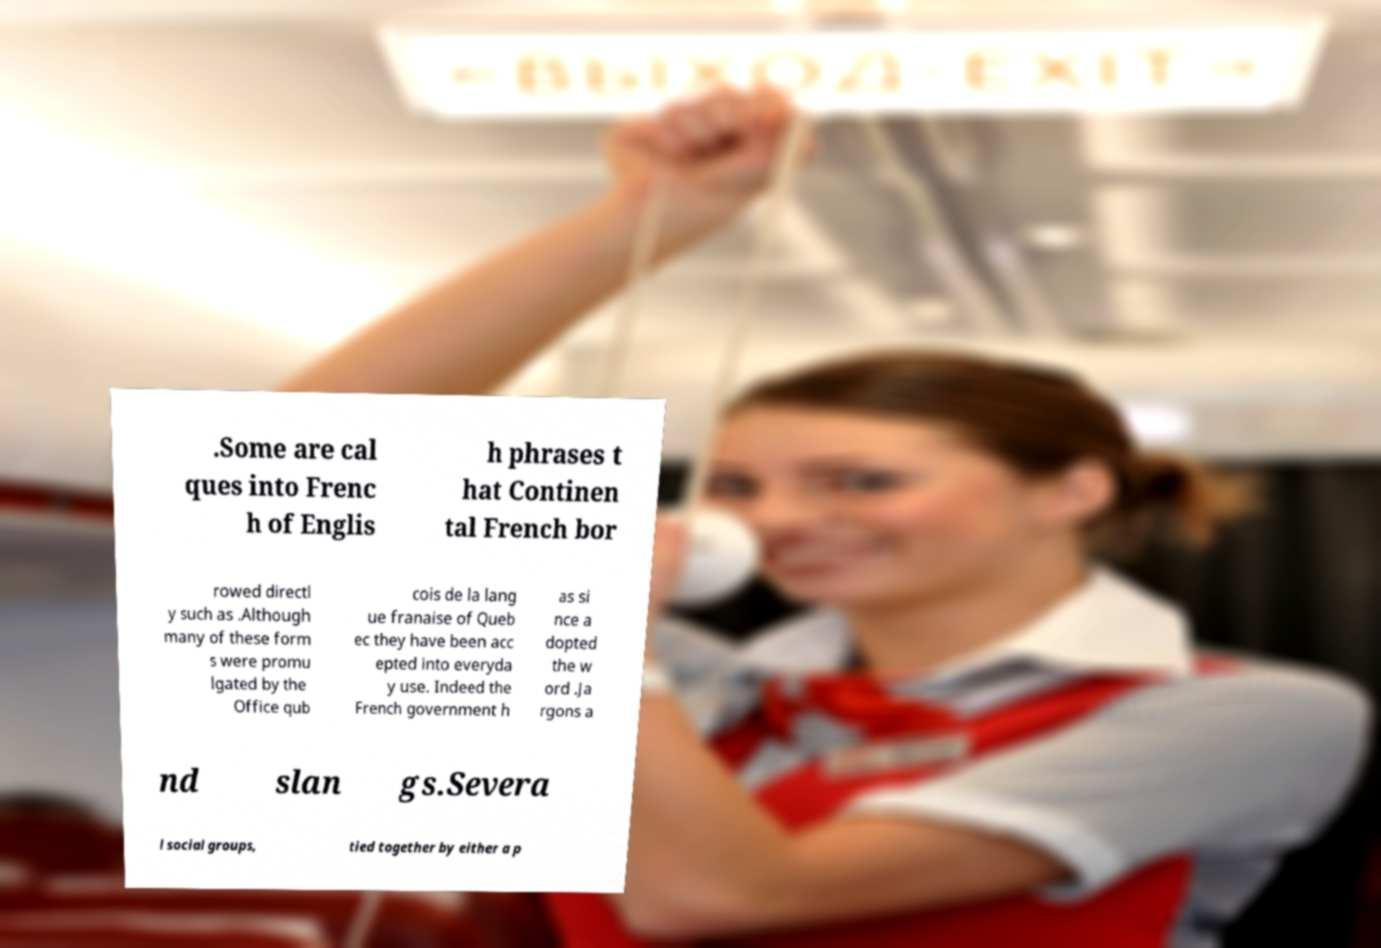Could you assist in decoding the text presented in this image and type it out clearly? .Some are cal ques into Frenc h of Englis h phrases t hat Continen tal French bor rowed directl y such as .Although many of these form s were promu lgated by the Office qub cois de la lang ue franaise of Queb ec they have been acc epted into everyda y use. Indeed the French government h as si nce a dopted the w ord .Ja rgons a nd slan gs.Severa l social groups, tied together by either a p 